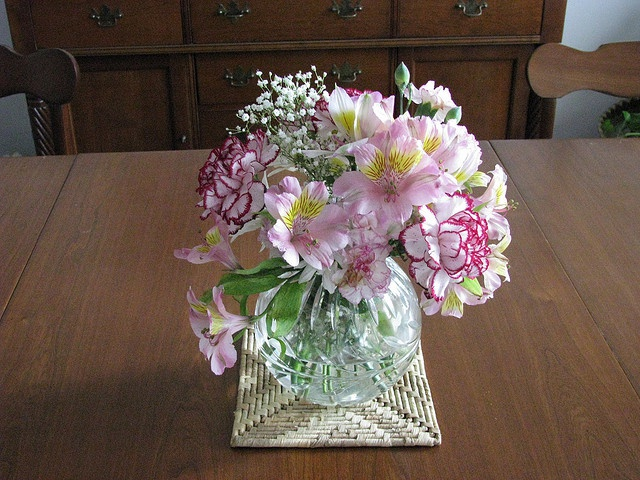Describe the objects in this image and their specific colors. I can see dining table in gray, maroon, and black tones, vase in gray, darkgray, and lightgray tones, chair in gray, maroon, brown, and black tones, and chair in gray and black tones in this image. 